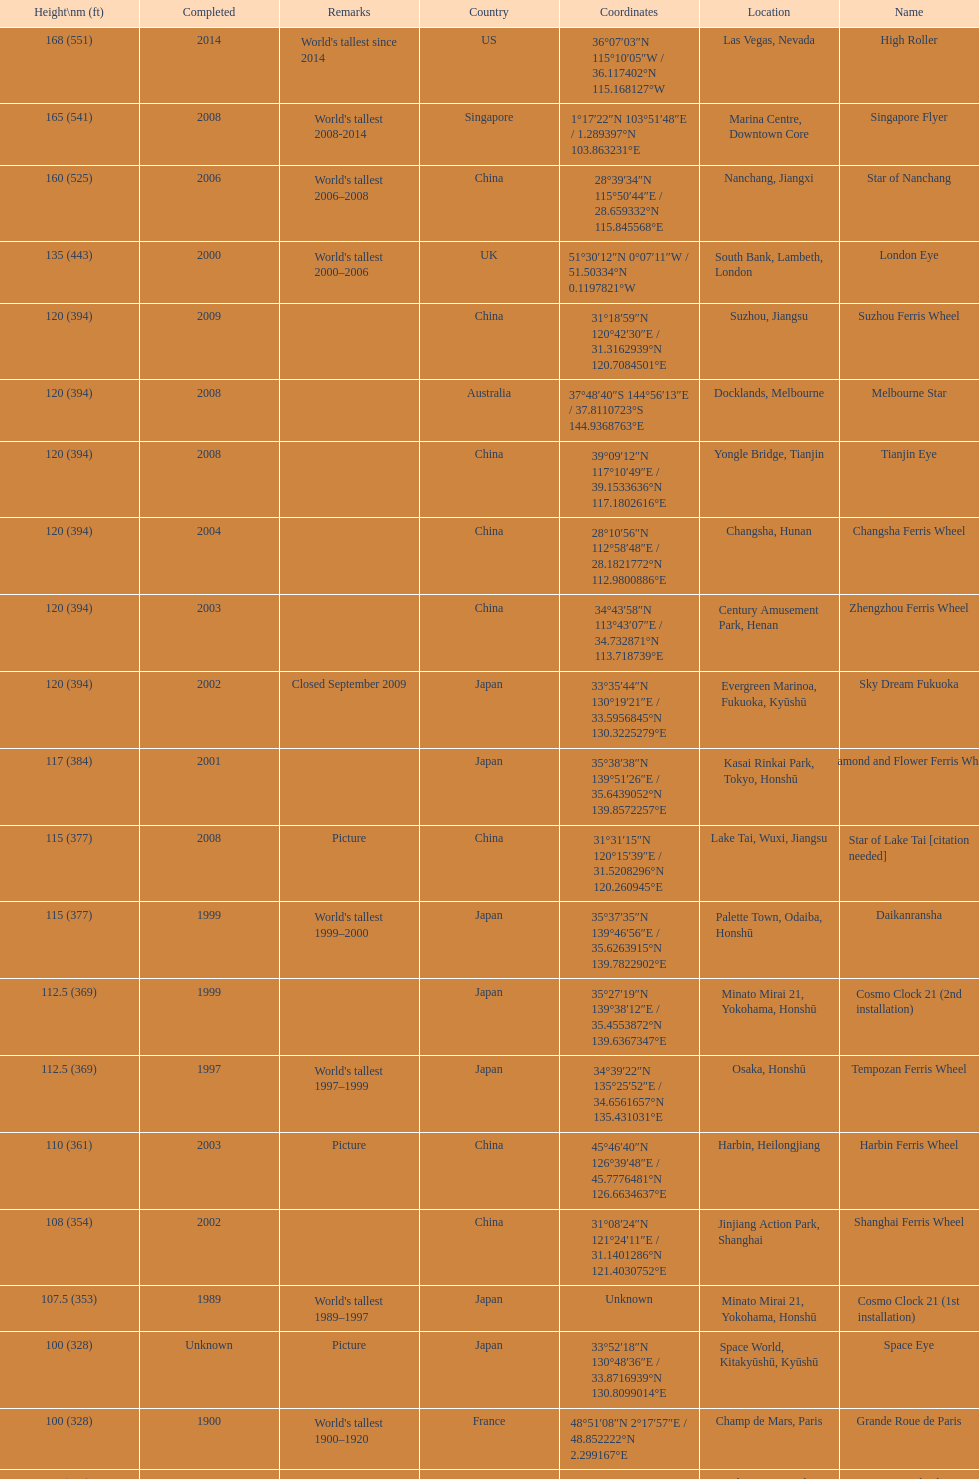Where was the original tallest roller coster built? Chicago. 